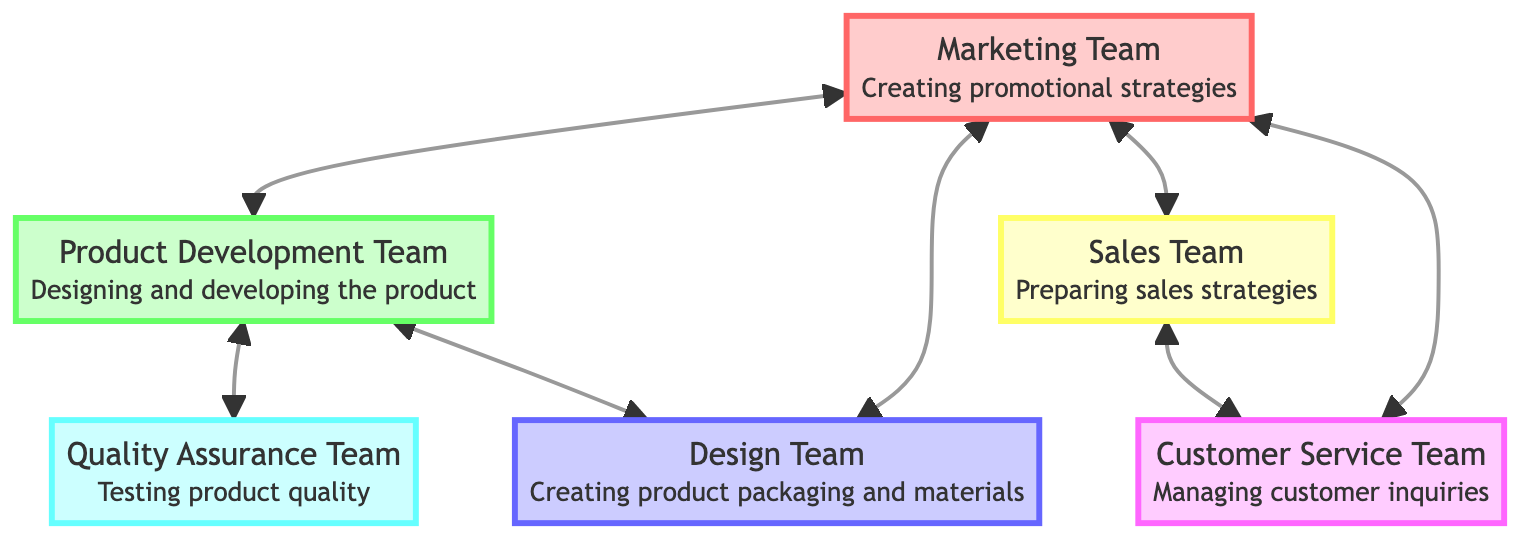What is the role of the Marketing Team? The Marketing Team is responsible for creating promotional strategies. This role is directly mentioned in the node corresponding to the Marketing Team in the diagram.
Answer: Creating promotional strategies How many departments are linked to the Product Development Team? The Product Development Team has three linked departments: Marketing Team, Quality Assurance Team, and Design Team. This can be observed directly from the connections in the diagram.
Answer: 3 Which two teams directly communicate with the Sales Team? The Sales Team is linked to the Marketing Team and Customer Service Team. This relationship is displayed in the diagram, indicating their direct communication paths.
Answer: Marketing Team, Customer Service Team What is the primary connection between the Quality Assurance Team and the Product Development Team? The connection between the Quality Assurance Team and the Product Development Team involves testing product quality and providing feedback. This relationship is explicitly stated in their respective nodes.
Answer: Testing product quality and providing feedback Which team has the most connections in the diagram? The Marketing Team has the most connections, linking with four departments: Product Development Team, Design Team, Sales Team, and Customer Service Team. This can be counted directly from the connections shown in the diagram.
Answer: Marketing Team What role does the Design Team play in this collaboration? The Design Team is tasked with creating product packaging and promotional materials, which is clearly indicated in its node.
Answer: Creating product packaging and promotional materials How does the Customer Service Team contribute to the overall product launch process? The Customer Service Team contributes by managing customer inquiries and feedback, and it also has direct communication with both the Sales Team and the Marketing Team, facilitating integration of customer insights in strategy.
Answer: Managing customer inquiries and feedback What can be inferred about the relationship between the Marketing Team and the Quality Assurance Team? The Marketing Team provides feedback to the Quality Assurance Team, which implies a collaboration that integrates market needs into product testing and quality assurance processes. This relationship is represented as a two-way link in the diagram.
Answer: Feedback loop between marketing and quality assurance How many total nodes are present in the diagram? There are six total nodes represented in the diagram: Marketing Team, Product Development Team, Design Team, Sales Team, Customer Service Team, and Quality Assurance Team. This can be counted directly from the nodes representing each team.
Answer: 6 